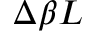Convert formula to latex. <formula><loc_0><loc_0><loc_500><loc_500>\Delta \beta L</formula> 